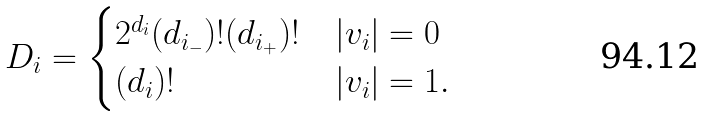Convert formula to latex. <formula><loc_0><loc_0><loc_500><loc_500>D _ { i } = \begin{cases} 2 ^ { d _ { i } } ( d _ { i _ { - } } ) ! ( d _ { i _ { + } } ) ! & | v _ { i } | = 0 \\ ( d _ { i } ) ! & | v _ { i } | = 1 . \end{cases}</formula> 